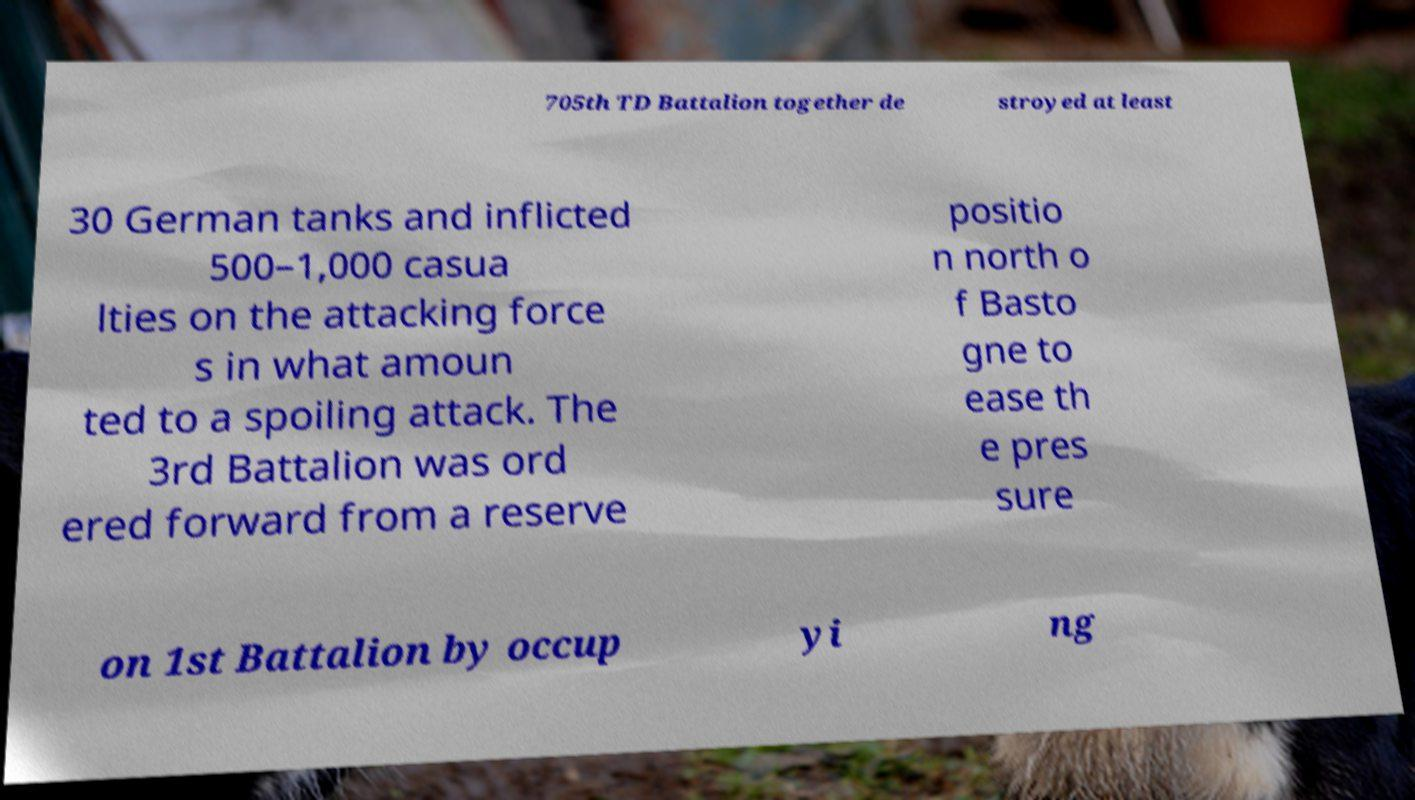Can you accurately transcribe the text from the provided image for me? 705th TD Battalion together de stroyed at least 30 German tanks and inflicted 500–1,000 casua lties on the attacking force s in what amoun ted to a spoiling attack. The 3rd Battalion was ord ered forward from a reserve positio n north o f Basto gne to ease th e pres sure on 1st Battalion by occup yi ng 